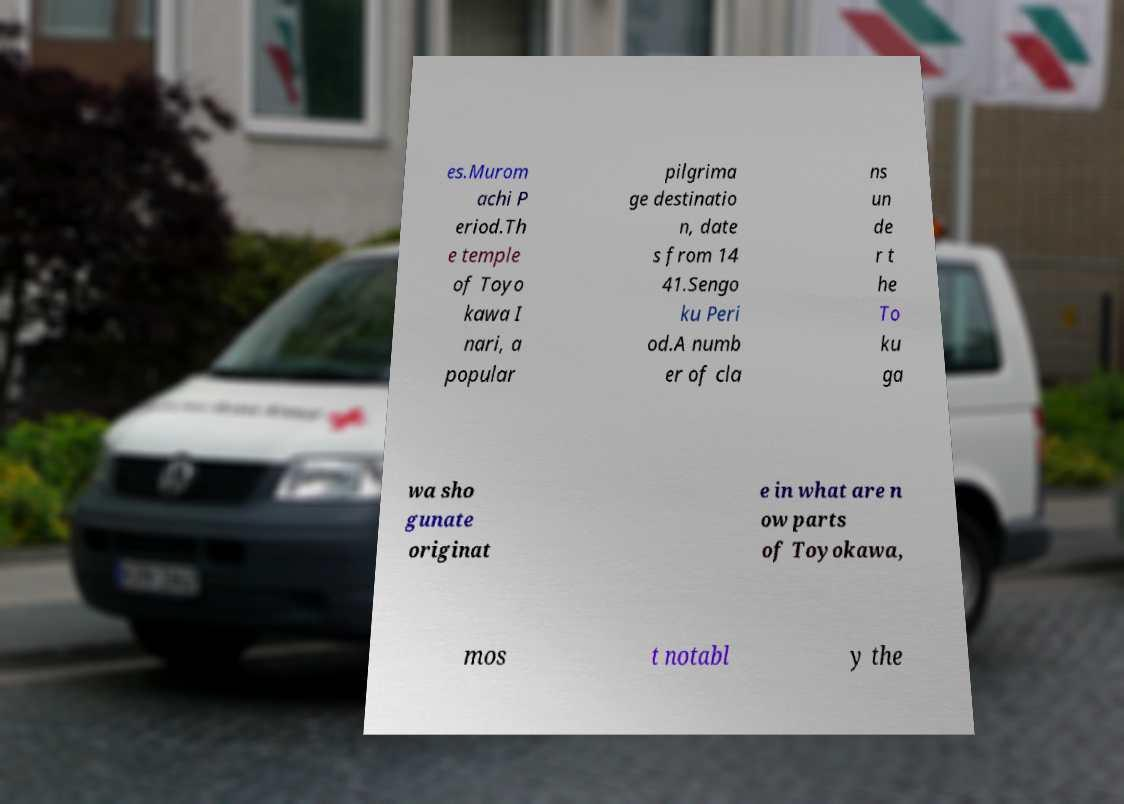Please identify and transcribe the text found in this image. es.Murom achi P eriod.Th e temple of Toyo kawa I nari, a popular pilgrima ge destinatio n, date s from 14 41.Sengo ku Peri od.A numb er of cla ns un de r t he To ku ga wa sho gunate originat e in what are n ow parts of Toyokawa, mos t notabl y the 